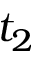Convert formula to latex. <formula><loc_0><loc_0><loc_500><loc_500>t _ { 2 }</formula> 